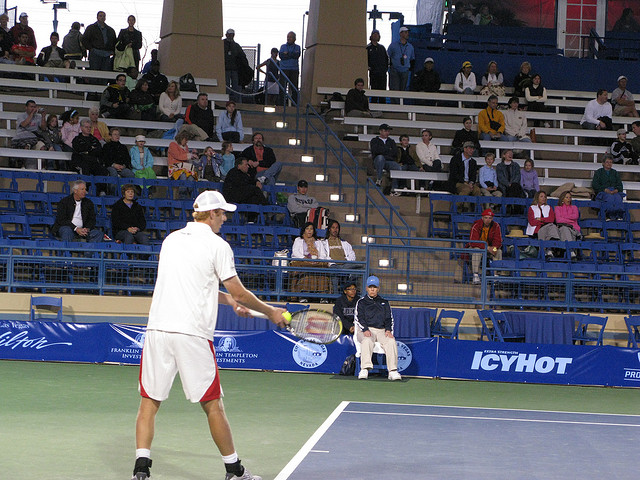Please transcribe the text information in this image. TSIMNTS PR ICYHOT 